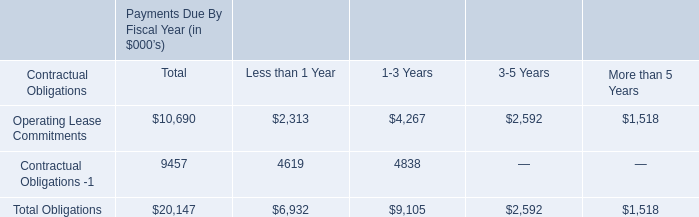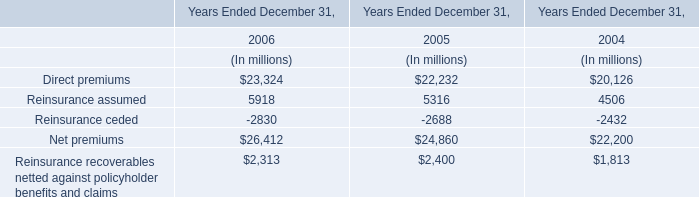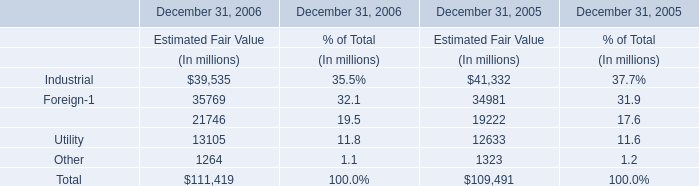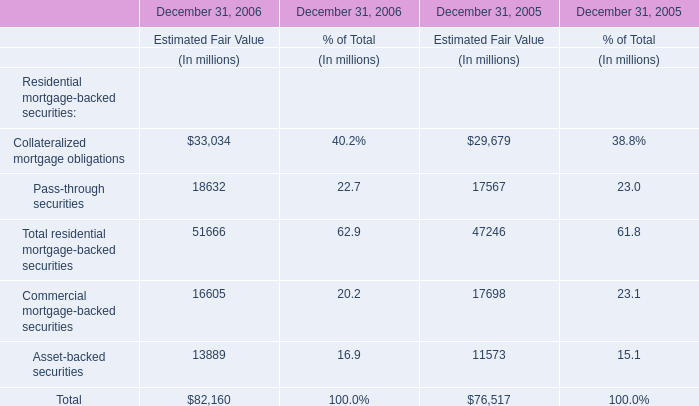If Pass-through securities of estimated fair value develops with the same increasing rate in 2006, what will it reach in 2007? (in million) 
Computations: ((((18632 - 17567) / 17567) + 1) * 18632)
Answer: 19761.56566. 